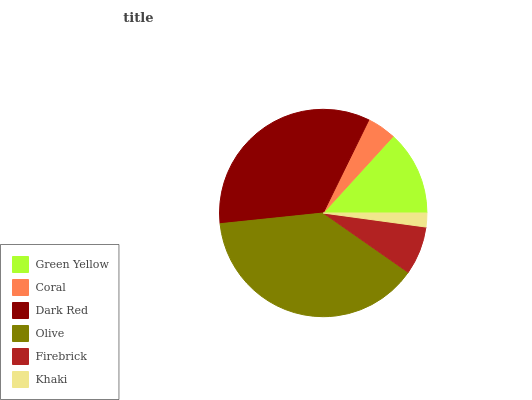Is Khaki the minimum?
Answer yes or no. Yes. Is Olive the maximum?
Answer yes or no. Yes. Is Coral the minimum?
Answer yes or no. No. Is Coral the maximum?
Answer yes or no. No. Is Green Yellow greater than Coral?
Answer yes or no. Yes. Is Coral less than Green Yellow?
Answer yes or no. Yes. Is Coral greater than Green Yellow?
Answer yes or no. No. Is Green Yellow less than Coral?
Answer yes or no. No. Is Green Yellow the high median?
Answer yes or no. Yes. Is Firebrick the low median?
Answer yes or no. Yes. Is Olive the high median?
Answer yes or no. No. Is Khaki the low median?
Answer yes or no. No. 